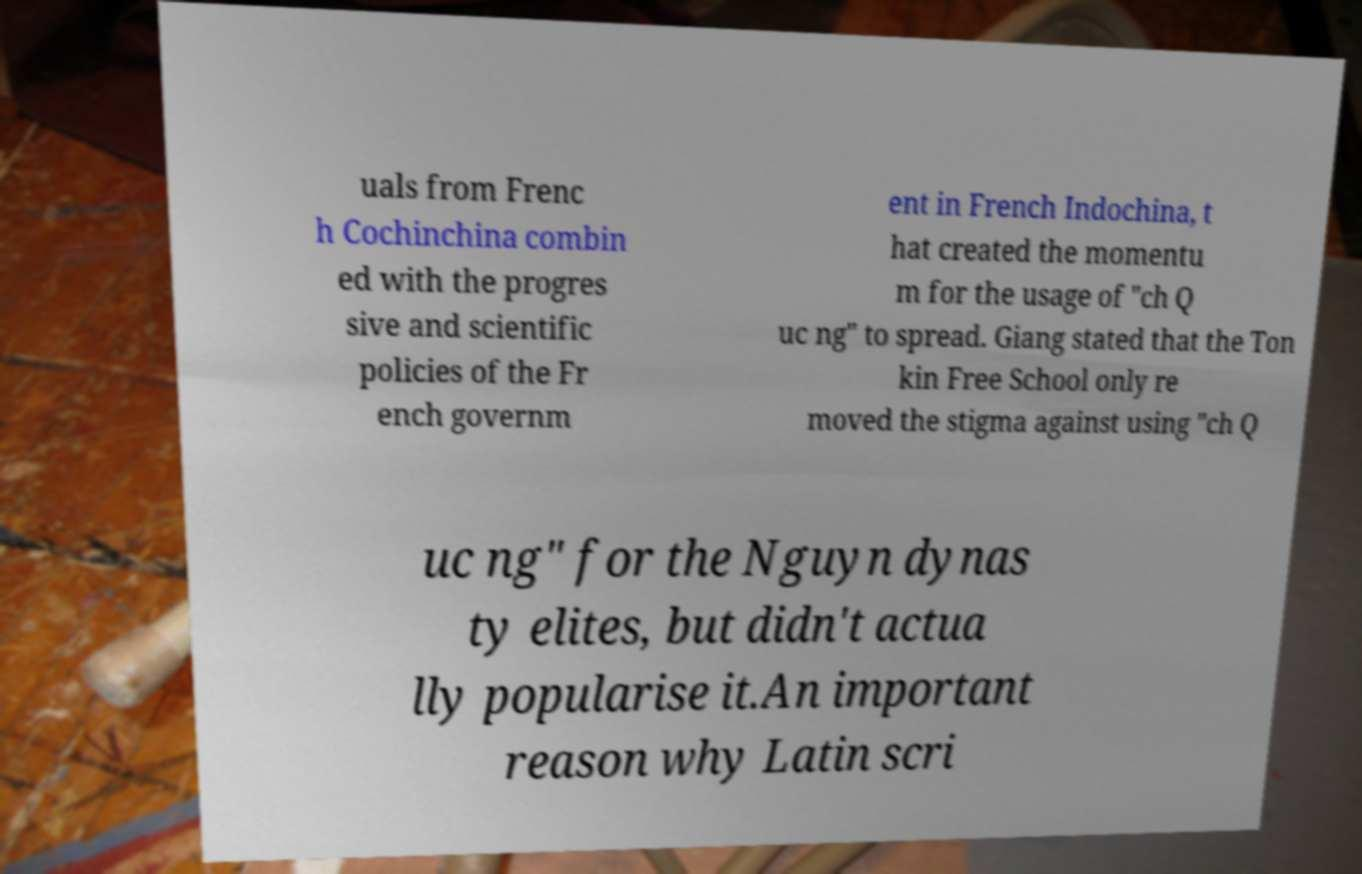Please identify and transcribe the text found in this image. uals from Frenc h Cochinchina combin ed with the progres sive and scientific policies of the Fr ench governm ent in French Indochina, t hat created the momentu m for the usage of "ch Q uc ng" to spread. Giang stated that the Ton kin Free School only re moved the stigma against using "ch Q uc ng" for the Nguyn dynas ty elites, but didn't actua lly popularise it.An important reason why Latin scri 